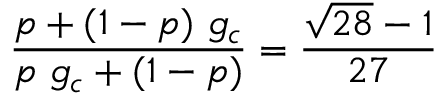<formula> <loc_0><loc_0><loc_500><loc_500>{ \frac { p + ( 1 - p ) \ g _ { c } } { p \ g _ { c } + ( 1 - p ) } } = { \frac { \sqrt { 2 8 } - 1 } { 2 7 } }</formula> 